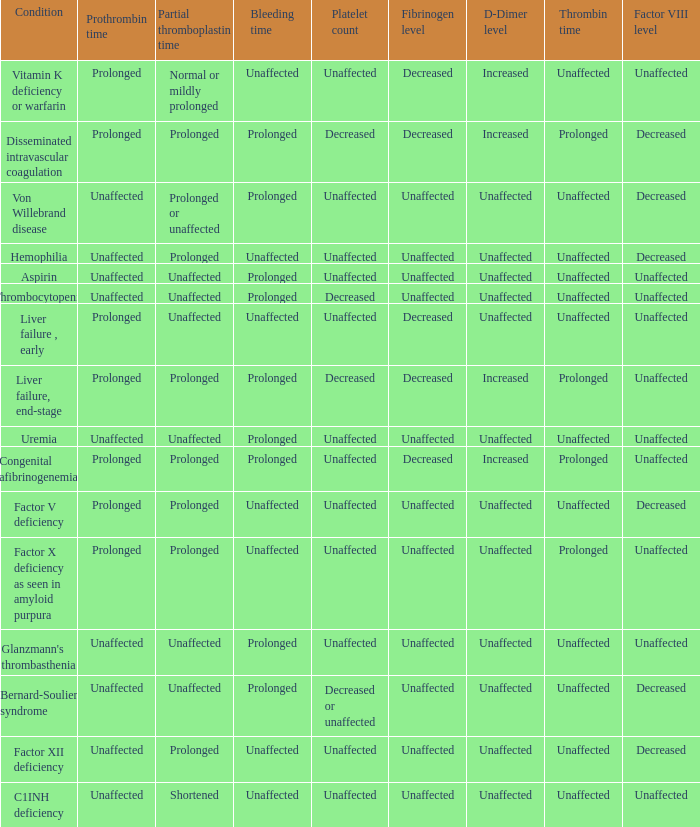Which Bleeding has a Condition of congenital afibrinogenemia? Prolonged. 